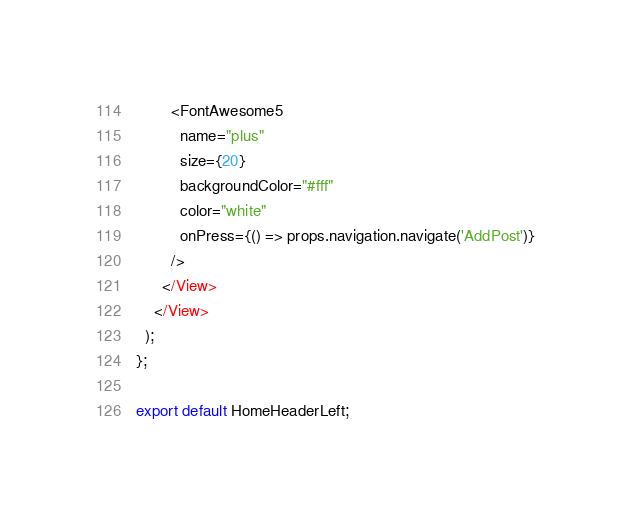Convert code to text. <code><loc_0><loc_0><loc_500><loc_500><_JavaScript_>        <FontAwesome5
          name="plus"
          size={20}
          backgroundColor="#fff"
          color="white"
          onPress={() => props.navigation.navigate('AddPost')}
        />
      </View>
    </View>
  );
};

export default HomeHeaderLeft;
</code> 